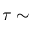<formula> <loc_0><loc_0><loc_500><loc_500>\tau \sim</formula> 